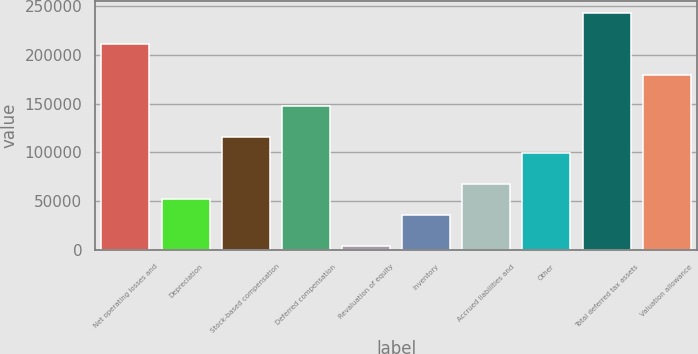Convert chart to OTSL. <chart><loc_0><loc_0><loc_500><loc_500><bar_chart><fcel>Net operating losses and<fcel>Depreciation<fcel>Stock-based compensation<fcel>Deferred compensation<fcel>Revaluation of equity<fcel>Inventory<fcel>Accrued liabilities and<fcel>Other<fcel>Total deferred tax assets<fcel>Valuation allowance<nl><fcel>211090<fcel>52333.8<fcel>115836<fcel>147587<fcel>4707<fcel>36458.2<fcel>68209.4<fcel>99960.6<fcel>242841<fcel>179339<nl></chart> 